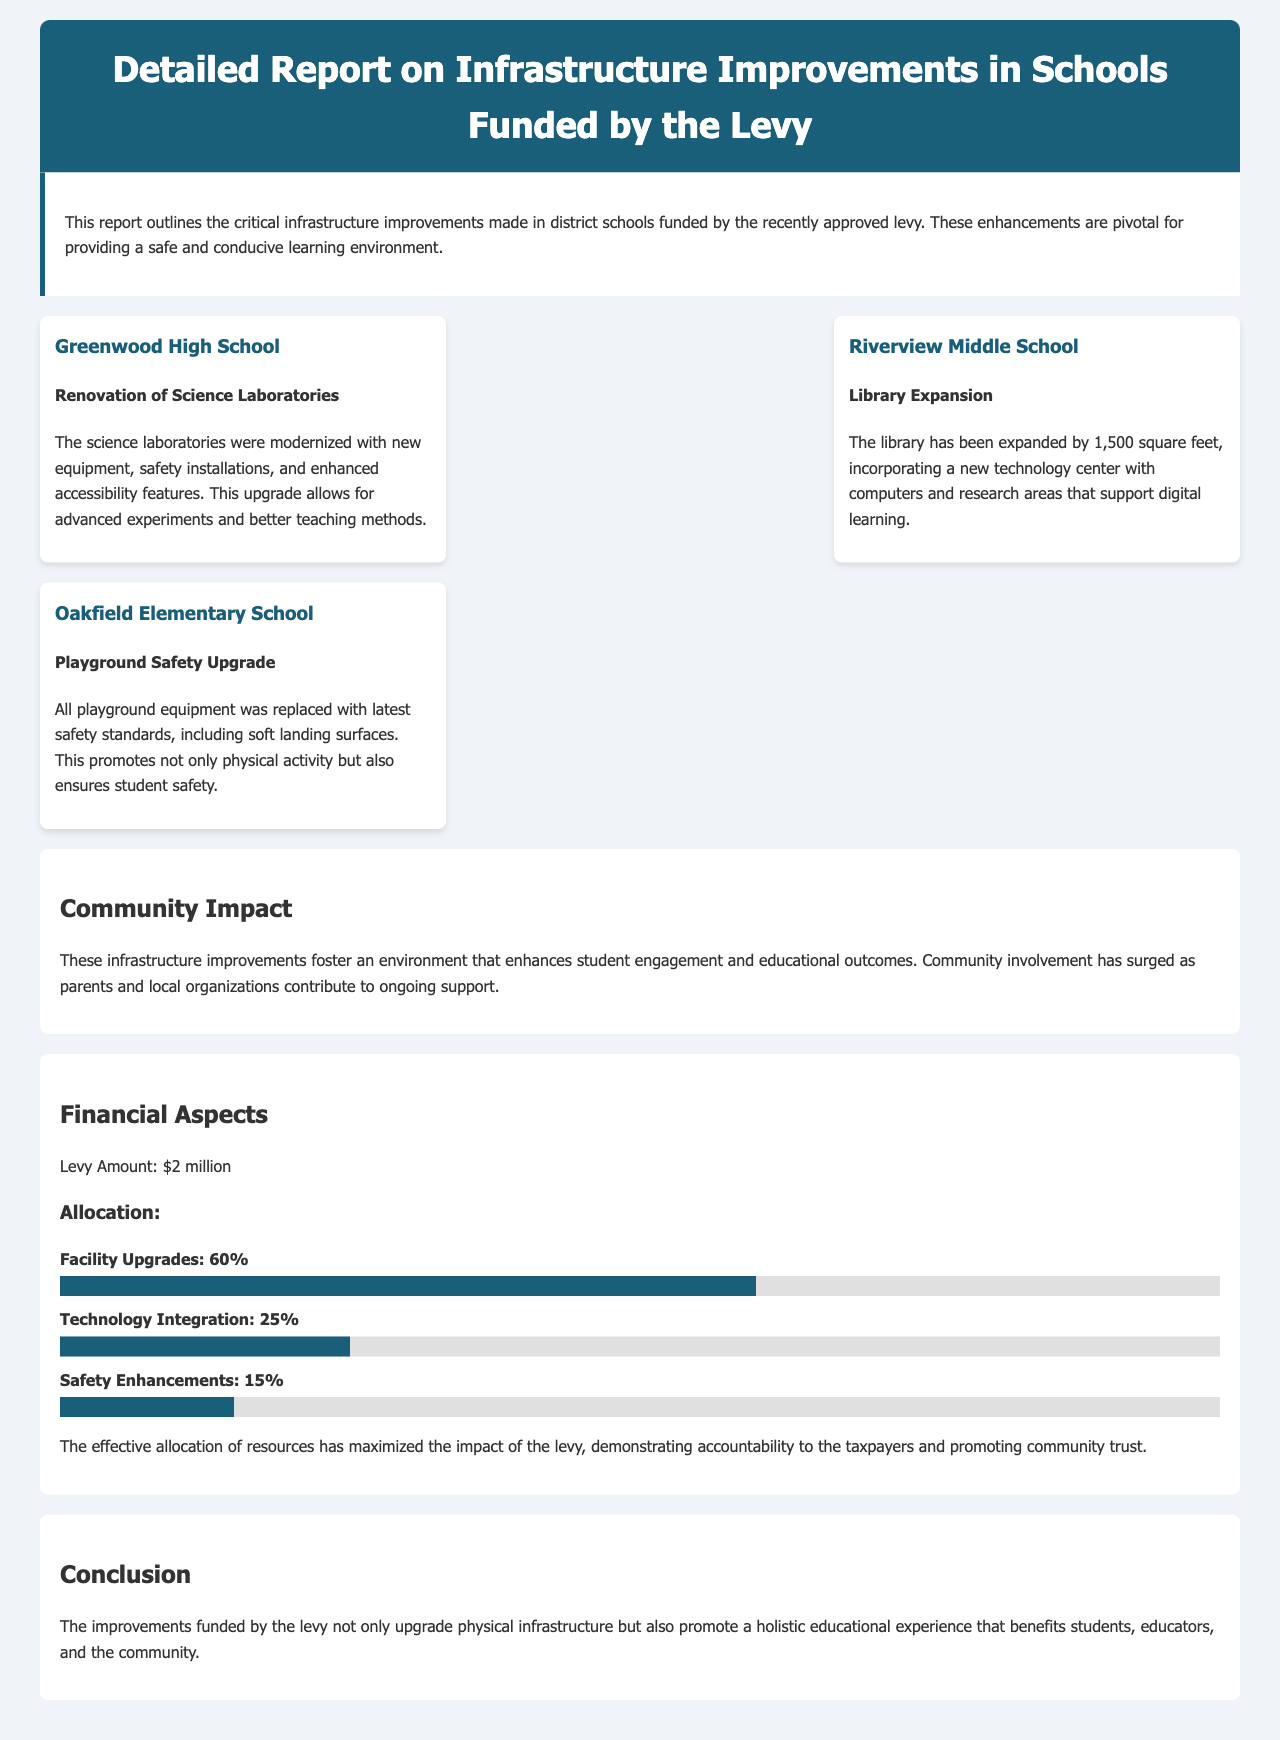What is the total amount of the levy? The total amount of the levy is clearly stated in the document as $2 million.
Answer: $2 million What percentage of the levy is allocated to facility upgrades? The document specifies that 60% of the levy is allocated to facility upgrades.
Answer: 60% What school had a library expansion? The report mentions that Riverview Middle School had a library expansion.
Answer: Riverview Middle School What was replaced in Oakfield Elementary School? The document indicates that all playground equipment was replaced in Oakfield Elementary School.
Answer: Playground equipment What is the main purpose of the infrastructure improvements? The report emphasizes that the purpose of the improvements is to provide a safe and conducive learning environment.
Answer: Safe and conducive learning environment Which school underwent modernization of science laboratories? The document states that Greenwood High School underwent modernization of science laboratories.
Answer: Greenwood High School What percentage of the levy is allocated to safety enhancements? The document notes that 15% of the levy is allocated to safety enhancements.
Answer: 15% What community involvement has surged due to the improvements? The document mentions that community involvement has surged as parents and local organizations contribute to ongoing support.
Answer: Ongoing support What is the overall impact of the levy on educational outcomes? The report states that the infrastructure improvements foster an environment that enhances student engagement and educational outcomes.
Answer: Enhances student engagement and educational outcomes 